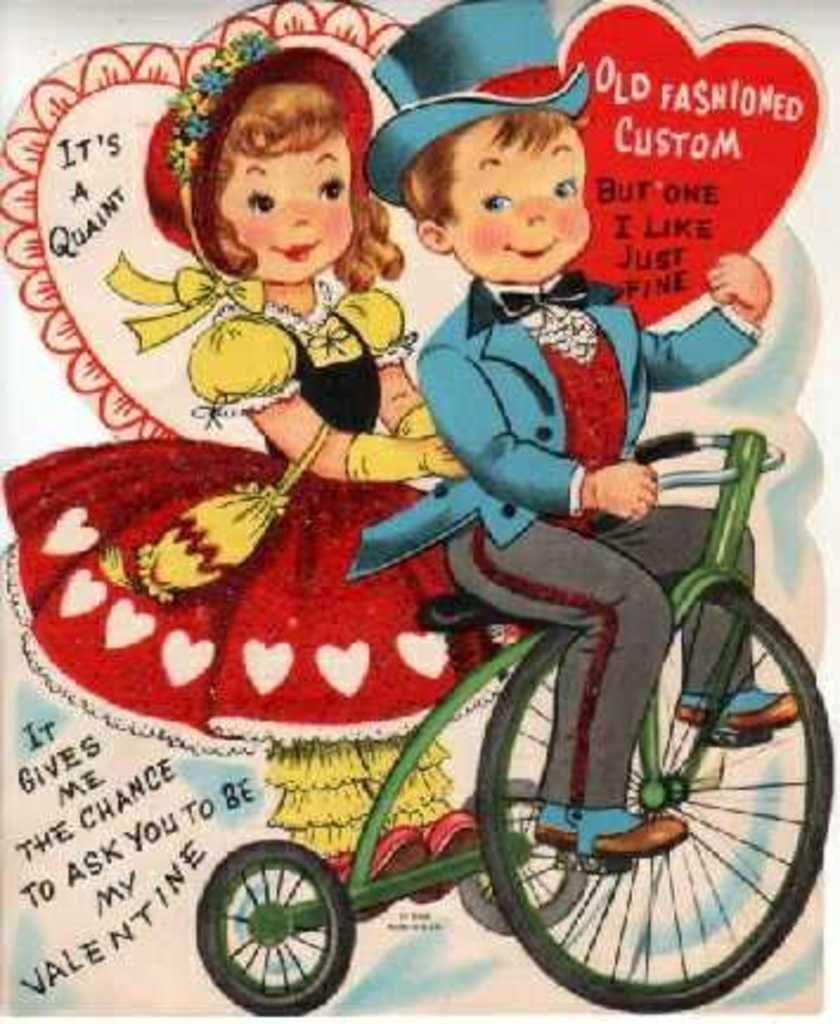What is the main subject of the poster in the image? The poster features a boy holding a text card. What is the boy doing in the image? The boy is also riding a bicycle with a girl in the image. Can you read any text on the poster? Yes, there is visible text is present on the poster. How does the boy manage to play an instrument while riding the bicycle in the image? There is no instrument present in the image; the boy is only riding a bicycle with a girl. 